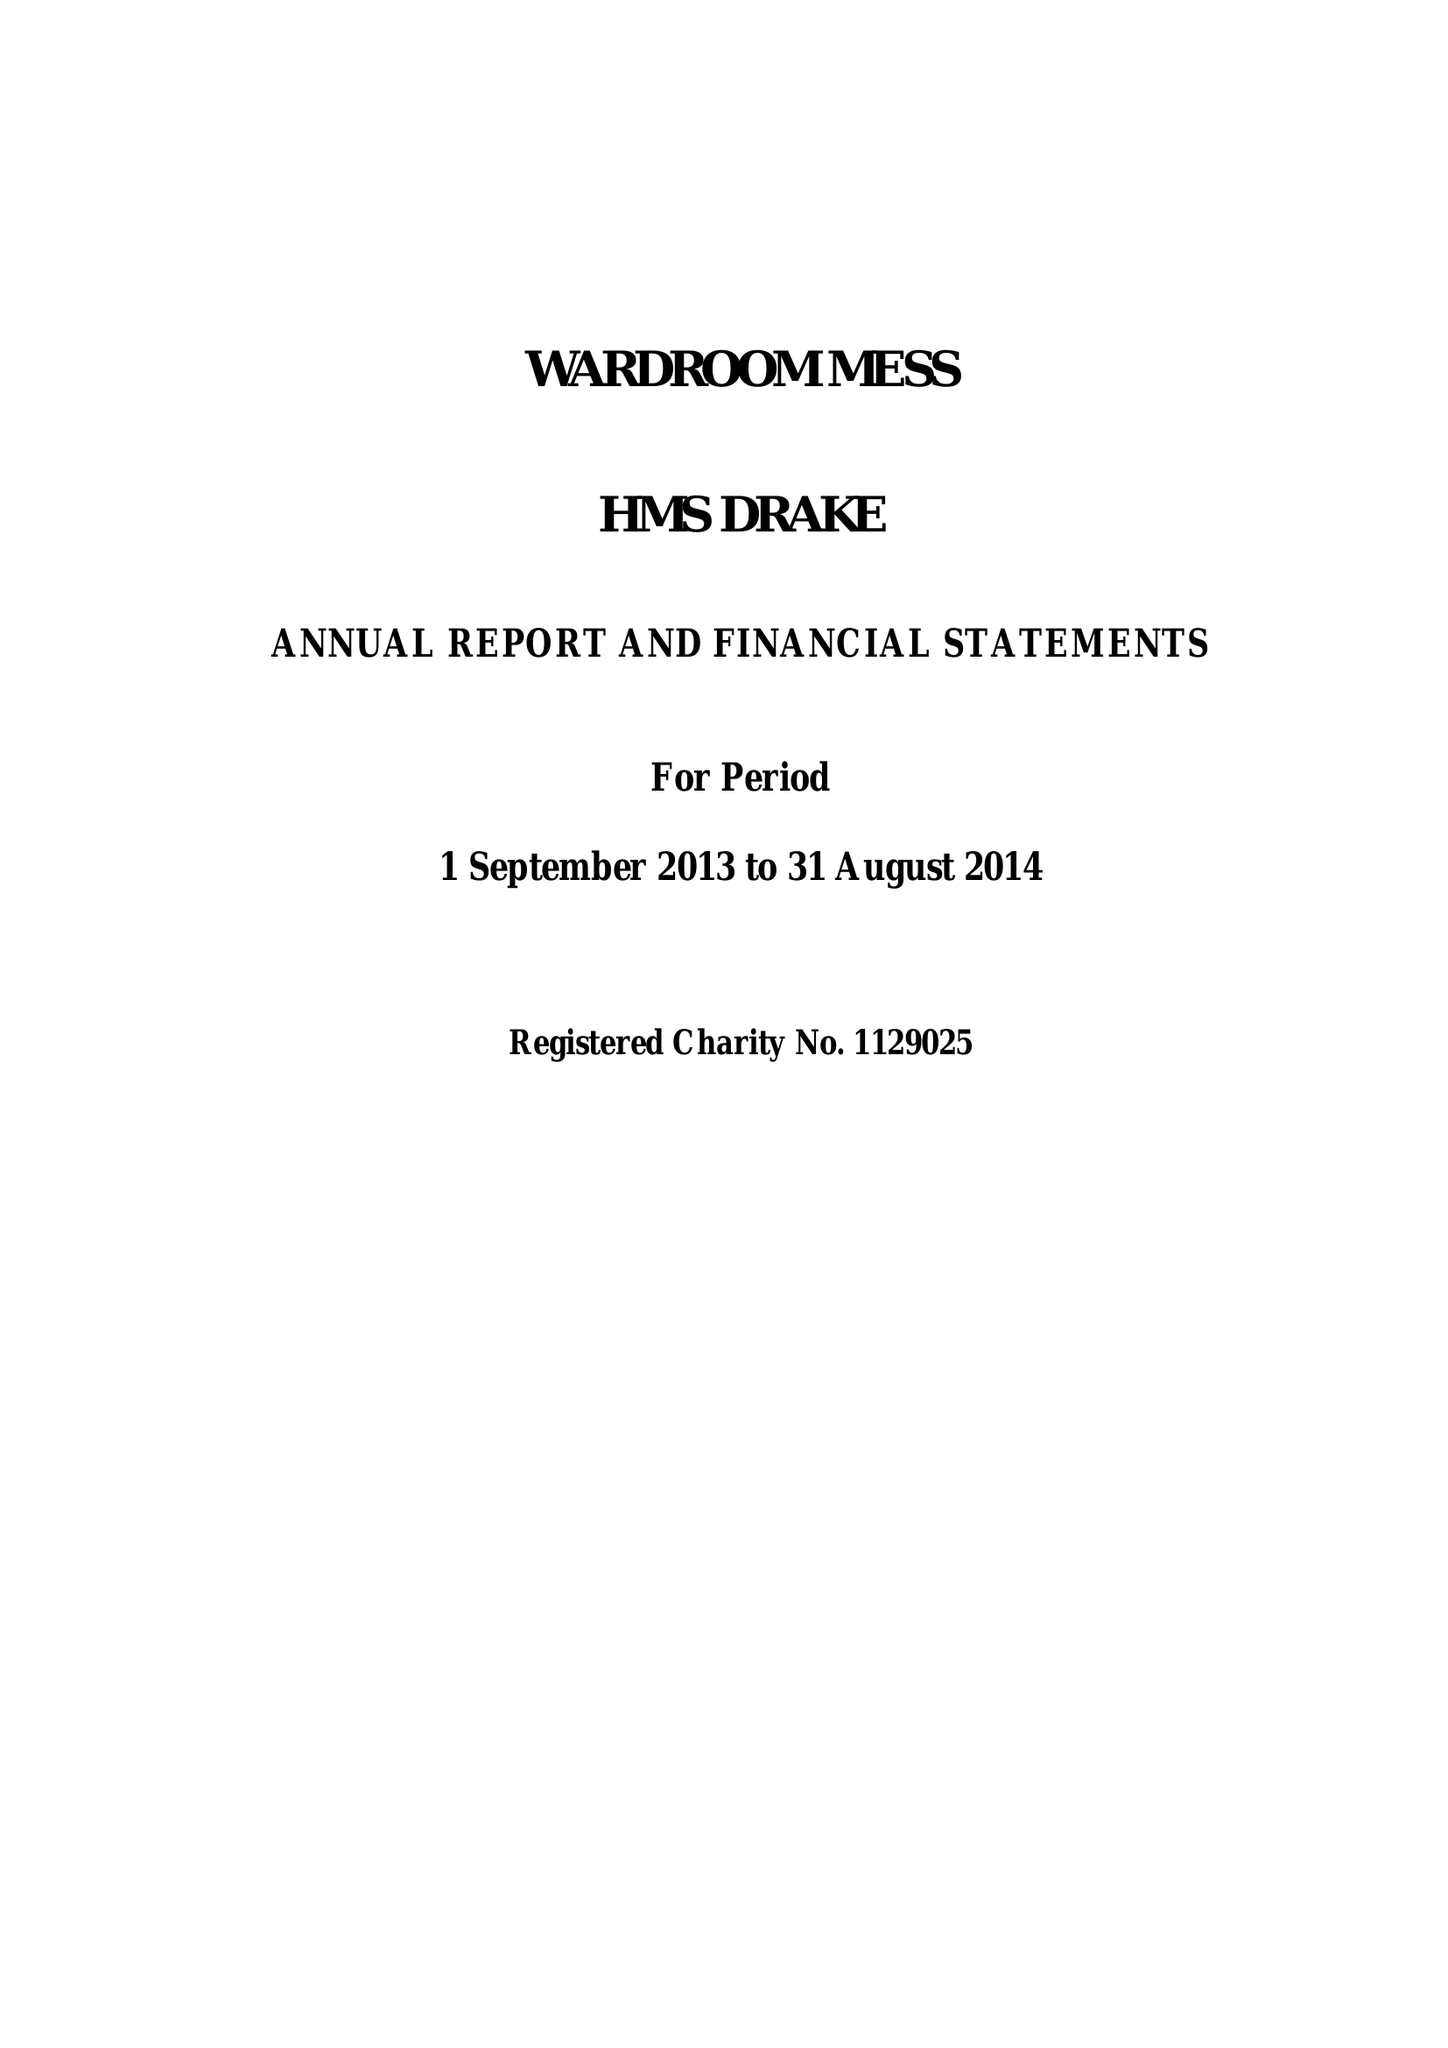What is the value for the address__post_town?
Answer the question using a single word or phrase. PLYMOUTH 